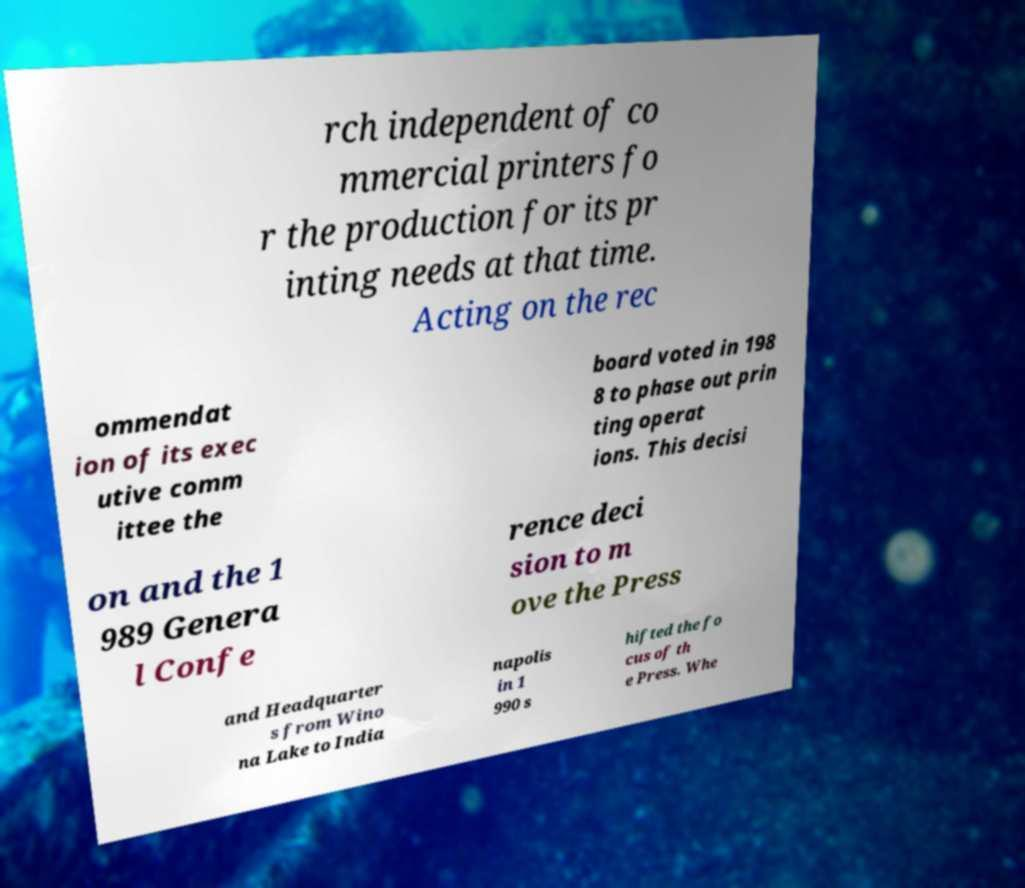Could you assist in decoding the text presented in this image and type it out clearly? rch independent of co mmercial printers fo r the production for its pr inting needs at that time. Acting on the rec ommendat ion of its exec utive comm ittee the board voted in 198 8 to phase out prin ting operat ions. This decisi on and the 1 989 Genera l Confe rence deci sion to m ove the Press and Headquarter s from Wino na Lake to India napolis in 1 990 s hifted the fo cus of th e Press. Whe 